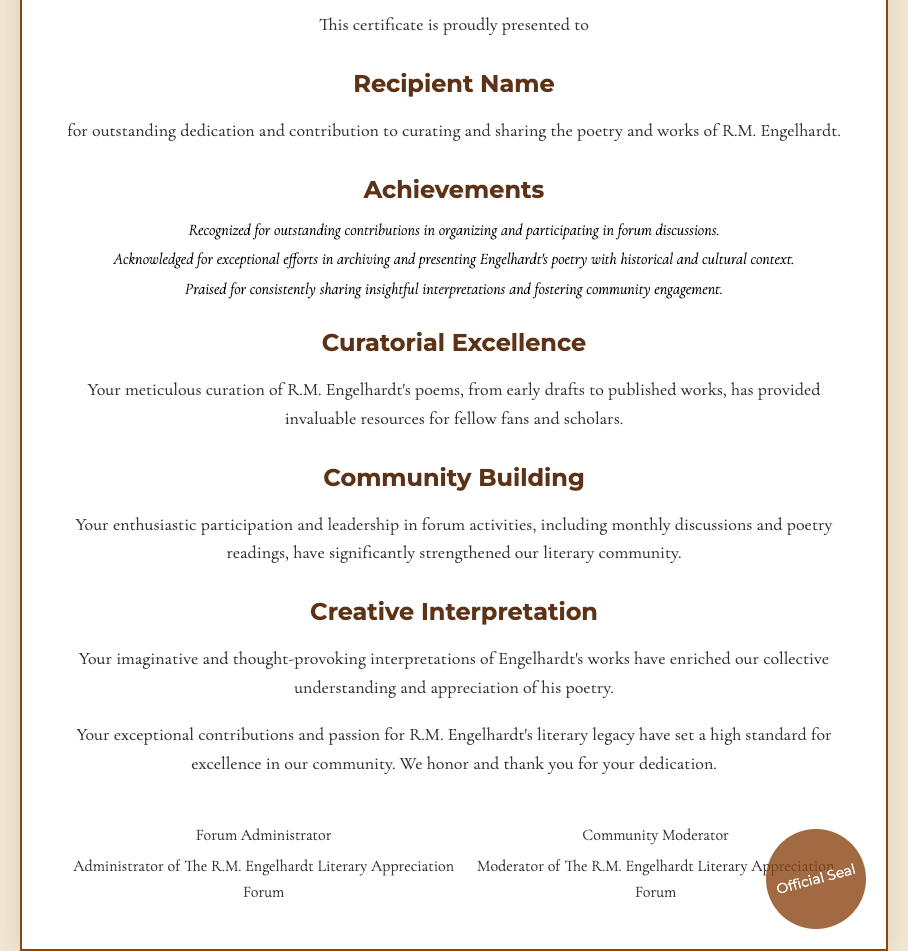what is the title of the certificate? The title of the certificate is prominently displayed at the top of the document.
Answer: Certificate of Excellence in Curating and Sharing R.M. Engelhardt's Works who is the certificate presented to? The recipient's name is indicated where it says "Recipient Name."
Answer: Recipient Name how many achievements are listed in the document? There are three specific achievements listed under the achievements section.
Answer: 3 who are the signatories of the certificate? The names and titles of the signatories are mentioned in the signature section.
Answer: Forum Administrator and Community Moderator what type of interpretations does the document praise? The document describes the interpretations as imaginative and thought-provoking.
Answer: imaginative and thought-provoking what has the recipient provided for fellow fans and scholars? The document states that the recipient has provided invaluable resources for fellow fans and scholars.
Answer: invaluable resources what is highlighted as a key contribution of the recipient? The document mentions the recipient's role in organizing and participating in forum discussions.
Answer: organizing and participating in forum discussions what is the visual seal at the bottom of the certificate labeled as? The seal at the bottom of the certificate has an official designation.
Answer: Official Seal 